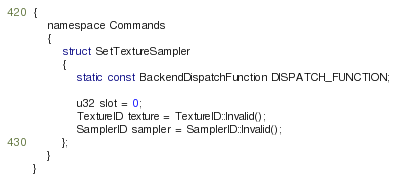Convert code to text. <code><loc_0><loc_0><loc_500><loc_500><_C_>{
    namespace Commands
    {
        struct SetTextureSampler
        {
            static const BackendDispatchFunction DISPATCH_FUNCTION;

            u32 slot = 0;
            TextureID texture = TextureID::Invalid();
            SamplerID sampler = SamplerID::Invalid();
        };
    }
}</code> 